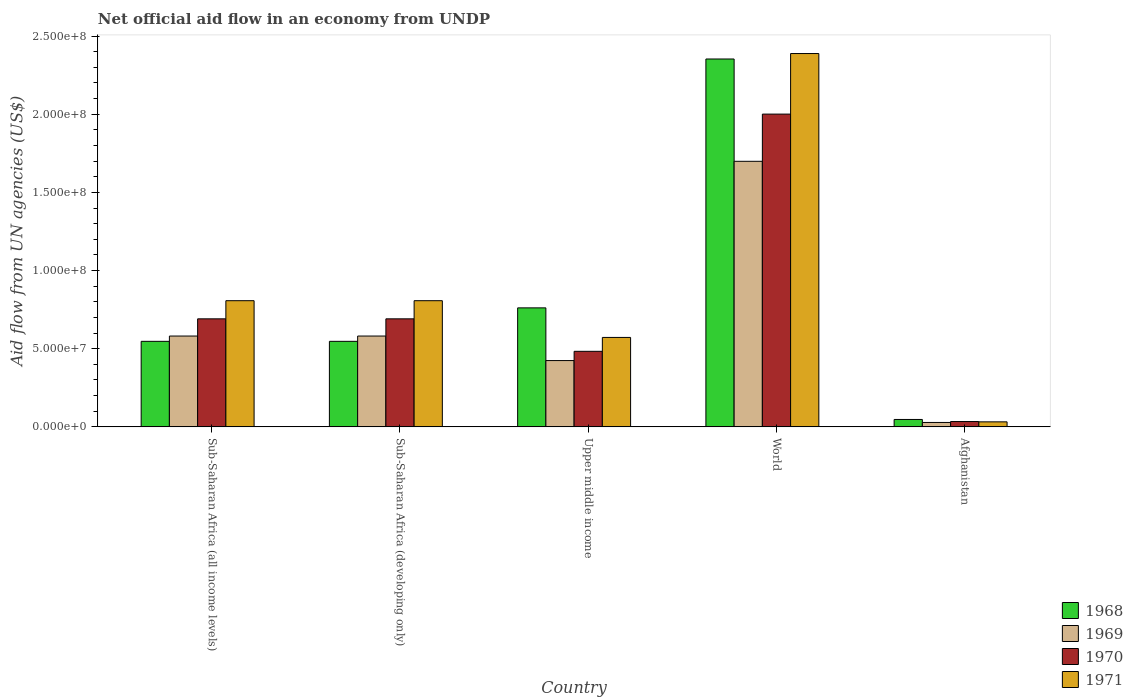Are the number of bars on each tick of the X-axis equal?
Make the answer very short. Yes. How many bars are there on the 2nd tick from the right?
Your response must be concise. 4. What is the label of the 5th group of bars from the left?
Offer a terse response. Afghanistan. In how many cases, is the number of bars for a given country not equal to the number of legend labels?
Your answer should be very brief. 0. What is the net official aid flow in 1970 in World?
Your answer should be very brief. 2.00e+08. Across all countries, what is the maximum net official aid flow in 1968?
Your answer should be very brief. 2.35e+08. Across all countries, what is the minimum net official aid flow in 1968?
Your answer should be very brief. 4.74e+06. In which country was the net official aid flow in 1969 minimum?
Your answer should be compact. Afghanistan. What is the total net official aid flow in 1971 in the graph?
Give a very brief answer. 4.61e+08. What is the difference between the net official aid flow in 1969 in Afghanistan and that in Upper middle income?
Make the answer very short. -3.96e+07. What is the difference between the net official aid flow in 1968 in Sub-Saharan Africa (all income levels) and the net official aid flow in 1969 in World?
Keep it short and to the point. -1.15e+08. What is the average net official aid flow in 1968 per country?
Provide a short and direct response. 8.51e+07. What is the difference between the net official aid flow of/in 1969 and net official aid flow of/in 1970 in Sub-Saharan Africa (developing only)?
Provide a succinct answer. -1.10e+07. In how many countries, is the net official aid flow in 1969 greater than 80000000 US$?
Your answer should be very brief. 1. What is the ratio of the net official aid flow in 1969 in Afghanistan to that in Sub-Saharan Africa (all income levels)?
Your answer should be very brief. 0.05. What is the difference between the highest and the second highest net official aid flow in 1968?
Make the answer very short. 1.81e+08. What is the difference between the highest and the lowest net official aid flow in 1968?
Give a very brief answer. 2.31e+08. What does the 1st bar from the left in World represents?
Give a very brief answer. 1968. Are all the bars in the graph horizontal?
Your answer should be compact. No. How many countries are there in the graph?
Ensure brevity in your answer.  5. What is the difference between two consecutive major ticks on the Y-axis?
Offer a very short reply. 5.00e+07. Are the values on the major ticks of Y-axis written in scientific E-notation?
Offer a terse response. Yes. Does the graph contain grids?
Provide a succinct answer. No. Where does the legend appear in the graph?
Your answer should be very brief. Bottom right. What is the title of the graph?
Offer a very short reply. Net official aid flow in an economy from UNDP. Does "1998" appear as one of the legend labels in the graph?
Give a very brief answer. No. What is the label or title of the Y-axis?
Offer a very short reply. Aid flow from UN agencies (US$). What is the Aid flow from UN agencies (US$) of 1968 in Sub-Saharan Africa (all income levels)?
Your response must be concise. 5.47e+07. What is the Aid flow from UN agencies (US$) of 1969 in Sub-Saharan Africa (all income levels)?
Provide a succinct answer. 5.81e+07. What is the Aid flow from UN agencies (US$) in 1970 in Sub-Saharan Africa (all income levels)?
Give a very brief answer. 6.91e+07. What is the Aid flow from UN agencies (US$) of 1971 in Sub-Saharan Africa (all income levels)?
Provide a short and direct response. 8.07e+07. What is the Aid flow from UN agencies (US$) of 1968 in Sub-Saharan Africa (developing only)?
Make the answer very short. 5.47e+07. What is the Aid flow from UN agencies (US$) in 1969 in Sub-Saharan Africa (developing only)?
Your answer should be compact. 5.81e+07. What is the Aid flow from UN agencies (US$) in 1970 in Sub-Saharan Africa (developing only)?
Your response must be concise. 6.91e+07. What is the Aid flow from UN agencies (US$) of 1971 in Sub-Saharan Africa (developing only)?
Your answer should be very brief. 8.07e+07. What is the Aid flow from UN agencies (US$) of 1968 in Upper middle income?
Your answer should be very brief. 7.61e+07. What is the Aid flow from UN agencies (US$) of 1969 in Upper middle income?
Your answer should be very brief. 4.24e+07. What is the Aid flow from UN agencies (US$) in 1970 in Upper middle income?
Your answer should be compact. 4.83e+07. What is the Aid flow from UN agencies (US$) of 1971 in Upper middle income?
Provide a succinct answer. 5.72e+07. What is the Aid flow from UN agencies (US$) in 1968 in World?
Keep it short and to the point. 2.35e+08. What is the Aid flow from UN agencies (US$) in 1969 in World?
Ensure brevity in your answer.  1.70e+08. What is the Aid flow from UN agencies (US$) of 1970 in World?
Ensure brevity in your answer.  2.00e+08. What is the Aid flow from UN agencies (US$) in 1971 in World?
Give a very brief answer. 2.39e+08. What is the Aid flow from UN agencies (US$) in 1968 in Afghanistan?
Offer a very short reply. 4.74e+06. What is the Aid flow from UN agencies (US$) of 1969 in Afghanistan?
Offer a terse response. 2.82e+06. What is the Aid flow from UN agencies (US$) of 1970 in Afghanistan?
Offer a terse response. 3.41e+06. What is the Aid flow from UN agencies (US$) in 1971 in Afghanistan?
Offer a very short reply. 3.21e+06. Across all countries, what is the maximum Aid flow from UN agencies (US$) in 1968?
Your answer should be very brief. 2.35e+08. Across all countries, what is the maximum Aid flow from UN agencies (US$) of 1969?
Offer a terse response. 1.70e+08. Across all countries, what is the maximum Aid flow from UN agencies (US$) of 1970?
Provide a short and direct response. 2.00e+08. Across all countries, what is the maximum Aid flow from UN agencies (US$) of 1971?
Your answer should be very brief. 2.39e+08. Across all countries, what is the minimum Aid flow from UN agencies (US$) in 1968?
Offer a very short reply. 4.74e+06. Across all countries, what is the minimum Aid flow from UN agencies (US$) of 1969?
Your answer should be very brief. 2.82e+06. Across all countries, what is the minimum Aid flow from UN agencies (US$) in 1970?
Provide a short and direct response. 3.41e+06. Across all countries, what is the minimum Aid flow from UN agencies (US$) in 1971?
Your response must be concise. 3.21e+06. What is the total Aid flow from UN agencies (US$) in 1968 in the graph?
Your response must be concise. 4.26e+08. What is the total Aid flow from UN agencies (US$) in 1969 in the graph?
Provide a succinct answer. 3.31e+08. What is the total Aid flow from UN agencies (US$) in 1970 in the graph?
Provide a succinct answer. 3.90e+08. What is the total Aid flow from UN agencies (US$) in 1971 in the graph?
Your response must be concise. 4.61e+08. What is the difference between the Aid flow from UN agencies (US$) of 1968 in Sub-Saharan Africa (all income levels) and that in Sub-Saharan Africa (developing only)?
Your response must be concise. 0. What is the difference between the Aid flow from UN agencies (US$) of 1969 in Sub-Saharan Africa (all income levels) and that in Sub-Saharan Africa (developing only)?
Offer a very short reply. 0. What is the difference between the Aid flow from UN agencies (US$) of 1968 in Sub-Saharan Africa (all income levels) and that in Upper middle income?
Keep it short and to the point. -2.14e+07. What is the difference between the Aid flow from UN agencies (US$) in 1969 in Sub-Saharan Africa (all income levels) and that in Upper middle income?
Your answer should be compact. 1.57e+07. What is the difference between the Aid flow from UN agencies (US$) of 1970 in Sub-Saharan Africa (all income levels) and that in Upper middle income?
Ensure brevity in your answer.  2.08e+07. What is the difference between the Aid flow from UN agencies (US$) of 1971 in Sub-Saharan Africa (all income levels) and that in Upper middle income?
Your response must be concise. 2.35e+07. What is the difference between the Aid flow from UN agencies (US$) of 1968 in Sub-Saharan Africa (all income levels) and that in World?
Make the answer very short. -1.81e+08. What is the difference between the Aid flow from UN agencies (US$) in 1969 in Sub-Saharan Africa (all income levels) and that in World?
Offer a very short reply. -1.12e+08. What is the difference between the Aid flow from UN agencies (US$) of 1970 in Sub-Saharan Africa (all income levels) and that in World?
Ensure brevity in your answer.  -1.31e+08. What is the difference between the Aid flow from UN agencies (US$) of 1971 in Sub-Saharan Africa (all income levels) and that in World?
Your answer should be very brief. -1.58e+08. What is the difference between the Aid flow from UN agencies (US$) of 1968 in Sub-Saharan Africa (all income levels) and that in Afghanistan?
Offer a very short reply. 5.00e+07. What is the difference between the Aid flow from UN agencies (US$) of 1969 in Sub-Saharan Africa (all income levels) and that in Afghanistan?
Ensure brevity in your answer.  5.53e+07. What is the difference between the Aid flow from UN agencies (US$) in 1970 in Sub-Saharan Africa (all income levels) and that in Afghanistan?
Your answer should be very brief. 6.57e+07. What is the difference between the Aid flow from UN agencies (US$) of 1971 in Sub-Saharan Africa (all income levels) and that in Afghanistan?
Offer a terse response. 7.75e+07. What is the difference between the Aid flow from UN agencies (US$) in 1968 in Sub-Saharan Africa (developing only) and that in Upper middle income?
Keep it short and to the point. -2.14e+07. What is the difference between the Aid flow from UN agencies (US$) in 1969 in Sub-Saharan Africa (developing only) and that in Upper middle income?
Provide a short and direct response. 1.57e+07. What is the difference between the Aid flow from UN agencies (US$) in 1970 in Sub-Saharan Africa (developing only) and that in Upper middle income?
Provide a succinct answer. 2.08e+07. What is the difference between the Aid flow from UN agencies (US$) in 1971 in Sub-Saharan Africa (developing only) and that in Upper middle income?
Provide a short and direct response. 2.35e+07. What is the difference between the Aid flow from UN agencies (US$) of 1968 in Sub-Saharan Africa (developing only) and that in World?
Offer a terse response. -1.81e+08. What is the difference between the Aid flow from UN agencies (US$) of 1969 in Sub-Saharan Africa (developing only) and that in World?
Offer a very short reply. -1.12e+08. What is the difference between the Aid flow from UN agencies (US$) of 1970 in Sub-Saharan Africa (developing only) and that in World?
Offer a terse response. -1.31e+08. What is the difference between the Aid flow from UN agencies (US$) of 1971 in Sub-Saharan Africa (developing only) and that in World?
Your answer should be very brief. -1.58e+08. What is the difference between the Aid flow from UN agencies (US$) in 1968 in Sub-Saharan Africa (developing only) and that in Afghanistan?
Your answer should be very brief. 5.00e+07. What is the difference between the Aid flow from UN agencies (US$) of 1969 in Sub-Saharan Africa (developing only) and that in Afghanistan?
Offer a very short reply. 5.53e+07. What is the difference between the Aid flow from UN agencies (US$) in 1970 in Sub-Saharan Africa (developing only) and that in Afghanistan?
Give a very brief answer. 6.57e+07. What is the difference between the Aid flow from UN agencies (US$) of 1971 in Sub-Saharan Africa (developing only) and that in Afghanistan?
Your response must be concise. 7.75e+07. What is the difference between the Aid flow from UN agencies (US$) in 1968 in Upper middle income and that in World?
Offer a very short reply. -1.59e+08. What is the difference between the Aid flow from UN agencies (US$) in 1969 in Upper middle income and that in World?
Offer a very short reply. -1.27e+08. What is the difference between the Aid flow from UN agencies (US$) of 1970 in Upper middle income and that in World?
Give a very brief answer. -1.52e+08. What is the difference between the Aid flow from UN agencies (US$) in 1971 in Upper middle income and that in World?
Your response must be concise. -1.82e+08. What is the difference between the Aid flow from UN agencies (US$) of 1968 in Upper middle income and that in Afghanistan?
Make the answer very short. 7.14e+07. What is the difference between the Aid flow from UN agencies (US$) of 1969 in Upper middle income and that in Afghanistan?
Your answer should be very brief. 3.96e+07. What is the difference between the Aid flow from UN agencies (US$) in 1970 in Upper middle income and that in Afghanistan?
Your answer should be compact. 4.49e+07. What is the difference between the Aid flow from UN agencies (US$) of 1971 in Upper middle income and that in Afghanistan?
Your answer should be very brief. 5.40e+07. What is the difference between the Aid flow from UN agencies (US$) in 1968 in World and that in Afghanistan?
Your response must be concise. 2.31e+08. What is the difference between the Aid flow from UN agencies (US$) in 1969 in World and that in Afghanistan?
Offer a terse response. 1.67e+08. What is the difference between the Aid flow from UN agencies (US$) of 1970 in World and that in Afghanistan?
Offer a very short reply. 1.97e+08. What is the difference between the Aid flow from UN agencies (US$) of 1971 in World and that in Afghanistan?
Provide a short and direct response. 2.36e+08. What is the difference between the Aid flow from UN agencies (US$) in 1968 in Sub-Saharan Africa (all income levels) and the Aid flow from UN agencies (US$) in 1969 in Sub-Saharan Africa (developing only)?
Offer a very short reply. -3.39e+06. What is the difference between the Aid flow from UN agencies (US$) of 1968 in Sub-Saharan Africa (all income levels) and the Aid flow from UN agencies (US$) of 1970 in Sub-Saharan Africa (developing only)?
Your answer should be very brief. -1.44e+07. What is the difference between the Aid flow from UN agencies (US$) in 1968 in Sub-Saharan Africa (all income levels) and the Aid flow from UN agencies (US$) in 1971 in Sub-Saharan Africa (developing only)?
Provide a succinct answer. -2.60e+07. What is the difference between the Aid flow from UN agencies (US$) in 1969 in Sub-Saharan Africa (all income levels) and the Aid flow from UN agencies (US$) in 1970 in Sub-Saharan Africa (developing only)?
Offer a terse response. -1.10e+07. What is the difference between the Aid flow from UN agencies (US$) in 1969 in Sub-Saharan Africa (all income levels) and the Aid flow from UN agencies (US$) in 1971 in Sub-Saharan Africa (developing only)?
Your answer should be compact. -2.26e+07. What is the difference between the Aid flow from UN agencies (US$) of 1970 in Sub-Saharan Africa (all income levels) and the Aid flow from UN agencies (US$) of 1971 in Sub-Saharan Africa (developing only)?
Keep it short and to the point. -1.16e+07. What is the difference between the Aid flow from UN agencies (US$) of 1968 in Sub-Saharan Africa (all income levels) and the Aid flow from UN agencies (US$) of 1969 in Upper middle income?
Keep it short and to the point. 1.23e+07. What is the difference between the Aid flow from UN agencies (US$) of 1968 in Sub-Saharan Africa (all income levels) and the Aid flow from UN agencies (US$) of 1970 in Upper middle income?
Make the answer very short. 6.38e+06. What is the difference between the Aid flow from UN agencies (US$) in 1968 in Sub-Saharan Africa (all income levels) and the Aid flow from UN agencies (US$) in 1971 in Upper middle income?
Provide a short and direct response. -2.50e+06. What is the difference between the Aid flow from UN agencies (US$) of 1969 in Sub-Saharan Africa (all income levels) and the Aid flow from UN agencies (US$) of 1970 in Upper middle income?
Your answer should be compact. 9.77e+06. What is the difference between the Aid flow from UN agencies (US$) of 1969 in Sub-Saharan Africa (all income levels) and the Aid flow from UN agencies (US$) of 1971 in Upper middle income?
Offer a terse response. 8.90e+05. What is the difference between the Aid flow from UN agencies (US$) in 1970 in Sub-Saharan Africa (all income levels) and the Aid flow from UN agencies (US$) in 1971 in Upper middle income?
Your response must be concise. 1.19e+07. What is the difference between the Aid flow from UN agencies (US$) in 1968 in Sub-Saharan Africa (all income levels) and the Aid flow from UN agencies (US$) in 1969 in World?
Make the answer very short. -1.15e+08. What is the difference between the Aid flow from UN agencies (US$) of 1968 in Sub-Saharan Africa (all income levels) and the Aid flow from UN agencies (US$) of 1970 in World?
Provide a succinct answer. -1.45e+08. What is the difference between the Aid flow from UN agencies (US$) of 1968 in Sub-Saharan Africa (all income levels) and the Aid flow from UN agencies (US$) of 1971 in World?
Your answer should be very brief. -1.84e+08. What is the difference between the Aid flow from UN agencies (US$) of 1969 in Sub-Saharan Africa (all income levels) and the Aid flow from UN agencies (US$) of 1970 in World?
Provide a short and direct response. -1.42e+08. What is the difference between the Aid flow from UN agencies (US$) in 1969 in Sub-Saharan Africa (all income levels) and the Aid flow from UN agencies (US$) in 1971 in World?
Offer a terse response. -1.81e+08. What is the difference between the Aid flow from UN agencies (US$) of 1970 in Sub-Saharan Africa (all income levels) and the Aid flow from UN agencies (US$) of 1971 in World?
Make the answer very short. -1.70e+08. What is the difference between the Aid flow from UN agencies (US$) of 1968 in Sub-Saharan Africa (all income levels) and the Aid flow from UN agencies (US$) of 1969 in Afghanistan?
Ensure brevity in your answer.  5.19e+07. What is the difference between the Aid flow from UN agencies (US$) in 1968 in Sub-Saharan Africa (all income levels) and the Aid flow from UN agencies (US$) in 1970 in Afghanistan?
Offer a terse response. 5.13e+07. What is the difference between the Aid flow from UN agencies (US$) of 1968 in Sub-Saharan Africa (all income levels) and the Aid flow from UN agencies (US$) of 1971 in Afghanistan?
Offer a very short reply. 5.15e+07. What is the difference between the Aid flow from UN agencies (US$) in 1969 in Sub-Saharan Africa (all income levels) and the Aid flow from UN agencies (US$) in 1970 in Afghanistan?
Give a very brief answer. 5.47e+07. What is the difference between the Aid flow from UN agencies (US$) in 1969 in Sub-Saharan Africa (all income levels) and the Aid flow from UN agencies (US$) in 1971 in Afghanistan?
Give a very brief answer. 5.49e+07. What is the difference between the Aid flow from UN agencies (US$) in 1970 in Sub-Saharan Africa (all income levels) and the Aid flow from UN agencies (US$) in 1971 in Afghanistan?
Give a very brief answer. 6.59e+07. What is the difference between the Aid flow from UN agencies (US$) of 1968 in Sub-Saharan Africa (developing only) and the Aid flow from UN agencies (US$) of 1969 in Upper middle income?
Your answer should be compact. 1.23e+07. What is the difference between the Aid flow from UN agencies (US$) of 1968 in Sub-Saharan Africa (developing only) and the Aid flow from UN agencies (US$) of 1970 in Upper middle income?
Offer a very short reply. 6.38e+06. What is the difference between the Aid flow from UN agencies (US$) in 1968 in Sub-Saharan Africa (developing only) and the Aid flow from UN agencies (US$) in 1971 in Upper middle income?
Provide a short and direct response. -2.50e+06. What is the difference between the Aid flow from UN agencies (US$) of 1969 in Sub-Saharan Africa (developing only) and the Aid flow from UN agencies (US$) of 1970 in Upper middle income?
Keep it short and to the point. 9.77e+06. What is the difference between the Aid flow from UN agencies (US$) in 1969 in Sub-Saharan Africa (developing only) and the Aid flow from UN agencies (US$) in 1971 in Upper middle income?
Your answer should be compact. 8.90e+05. What is the difference between the Aid flow from UN agencies (US$) in 1970 in Sub-Saharan Africa (developing only) and the Aid flow from UN agencies (US$) in 1971 in Upper middle income?
Make the answer very short. 1.19e+07. What is the difference between the Aid flow from UN agencies (US$) of 1968 in Sub-Saharan Africa (developing only) and the Aid flow from UN agencies (US$) of 1969 in World?
Ensure brevity in your answer.  -1.15e+08. What is the difference between the Aid flow from UN agencies (US$) in 1968 in Sub-Saharan Africa (developing only) and the Aid flow from UN agencies (US$) in 1970 in World?
Offer a very short reply. -1.45e+08. What is the difference between the Aid flow from UN agencies (US$) of 1968 in Sub-Saharan Africa (developing only) and the Aid flow from UN agencies (US$) of 1971 in World?
Provide a succinct answer. -1.84e+08. What is the difference between the Aid flow from UN agencies (US$) of 1969 in Sub-Saharan Africa (developing only) and the Aid flow from UN agencies (US$) of 1970 in World?
Give a very brief answer. -1.42e+08. What is the difference between the Aid flow from UN agencies (US$) in 1969 in Sub-Saharan Africa (developing only) and the Aid flow from UN agencies (US$) in 1971 in World?
Ensure brevity in your answer.  -1.81e+08. What is the difference between the Aid flow from UN agencies (US$) of 1970 in Sub-Saharan Africa (developing only) and the Aid flow from UN agencies (US$) of 1971 in World?
Your response must be concise. -1.70e+08. What is the difference between the Aid flow from UN agencies (US$) of 1968 in Sub-Saharan Africa (developing only) and the Aid flow from UN agencies (US$) of 1969 in Afghanistan?
Your answer should be very brief. 5.19e+07. What is the difference between the Aid flow from UN agencies (US$) of 1968 in Sub-Saharan Africa (developing only) and the Aid flow from UN agencies (US$) of 1970 in Afghanistan?
Offer a terse response. 5.13e+07. What is the difference between the Aid flow from UN agencies (US$) of 1968 in Sub-Saharan Africa (developing only) and the Aid flow from UN agencies (US$) of 1971 in Afghanistan?
Provide a short and direct response. 5.15e+07. What is the difference between the Aid flow from UN agencies (US$) in 1969 in Sub-Saharan Africa (developing only) and the Aid flow from UN agencies (US$) in 1970 in Afghanistan?
Your response must be concise. 5.47e+07. What is the difference between the Aid flow from UN agencies (US$) in 1969 in Sub-Saharan Africa (developing only) and the Aid flow from UN agencies (US$) in 1971 in Afghanistan?
Keep it short and to the point. 5.49e+07. What is the difference between the Aid flow from UN agencies (US$) of 1970 in Sub-Saharan Africa (developing only) and the Aid flow from UN agencies (US$) of 1971 in Afghanistan?
Your answer should be very brief. 6.59e+07. What is the difference between the Aid flow from UN agencies (US$) in 1968 in Upper middle income and the Aid flow from UN agencies (US$) in 1969 in World?
Provide a short and direct response. -9.38e+07. What is the difference between the Aid flow from UN agencies (US$) of 1968 in Upper middle income and the Aid flow from UN agencies (US$) of 1970 in World?
Offer a terse response. -1.24e+08. What is the difference between the Aid flow from UN agencies (US$) of 1968 in Upper middle income and the Aid flow from UN agencies (US$) of 1971 in World?
Your answer should be compact. -1.63e+08. What is the difference between the Aid flow from UN agencies (US$) in 1969 in Upper middle income and the Aid flow from UN agencies (US$) in 1970 in World?
Offer a very short reply. -1.58e+08. What is the difference between the Aid flow from UN agencies (US$) in 1969 in Upper middle income and the Aid flow from UN agencies (US$) in 1971 in World?
Your answer should be very brief. -1.96e+08. What is the difference between the Aid flow from UN agencies (US$) of 1970 in Upper middle income and the Aid flow from UN agencies (US$) of 1971 in World?
Provide a succinct answer. -1.90e+08. What is the difference between the Aid flow from UN agencies (US$) of 1968 in Upper middle income and the Aid flow from UN agencies (US$) of 1969 in Afghanistan?
Keep it short and to the point. 7.33e+07. What is the difference between the Aid flow from UN agencies (US$) of 1968 in Upper middle income and the Aid flow from UN agencies (US$) of 1970 in Afghanistan?
Keep it short and to the point. 7.27e+07. What is the difference between the Aid flow from UN agencies (US$) in 1968 in Upper middle income and the Aid flow from UN agencies (US$) in 1971 in Afghanistan?
Give a very brief answer. 7.29e+07. What is the difference between the Aid flow from UN agencies (US$) in 1969 in Upper middle income and the Aid flow from UN agencies (US$) in 1970 in Afghanistan?
Give a very brief answer. 3.90e+07. What is the difference between the Aid flow from UN agencies (US$) in 1969 in Upper middle income and the Aid flow from UN agencies (US$) in 1971 in Afghanistan?
Provide a succinct answer. 3.92e+07. What is the difference between the Aid flow from UN agencies (US$) in 1970 in Upper middle income and the Aid flow from UN agencies (US$) in 1971 in Afghanistan?
Provide a short and direct response. 4.51e+07. What is the difference between the Aid flow from UN agencies (US$) in 1968 in World and the Aid flow from UN agencies (US$) in 1969 in Afghanistan?
Keep it short and to the point. 2.32e+08. What is the difference between the Aid flow from UN agencies (US$) of 1968 in World and the Aid flow from UN agencies (US$) of 1970 in Afghanistan?
Your answer should be compact. 2.32e+08. What is the difference between the Aid flow from UN agencies (US$) of 1968 in World and the Aid flow from UN agencies (US$) of 1971 in Afghanistan?
Make the answer very short. 2.32e+08. What is the difference between the Aid flow from UN agencies (US$) in 1969 in World and the Aid flow from UN agencies (US$) in 1970 in Afghanistan?
Offer a terse response. 1.66e+08. What is the difference between the Aid flow from UN agencies (US$) in 1969 in World and the Aid flow from UN agencies (US$) in 1971 in Afghanistan?
Offer a very short reply. 1.67e+08. What is the difference between the Aid flow from UN agencies (US$) of 1970 in World and the Aid flow from UN agencies (US$) of 1971 in Afghanistan?
Your response must be concise. 1.97e+08. What is the average Aid flow from UN agencies (US$) of 1968 per country?
Keep it short and to the point. 8.51e+07. What is the average Aid flow from UN agencies (US$) of 1969 per country?
Offer a terse response. 6.63e+07. What is the average Aid flow from UN agencies (US$) of 1970 per country?
Provide a short and direct response. 7.80e+07. What is the average Aid flow from UN agencies (US$) in 1971 per country?
Ensure brevity in your answer.  9.21e+07. What is the difference between the Aid flow from UN agencies (US$) of 1968 and Aid flow from UN agencies (US$) of 1969 in Sub-Saharan Africa (all income levels)?
Your response must be concise. -3.39e+06. What is the difference between the Aid flow from UN agencies (US$) of 1968 and Aid flow from UN agencies (US$) of 1970 in Sub-Saharan Africa (all income levels)?
Give a very brief answer. -1.44e+07. What is the difference between the Aid flow from UN agencies (US$) in 1968 and Aid flow from UN agencies (US$) in 1971 in Sub-Saharan Africa (all income levels)?
Offer a very short reply. -2.60e+07. What is the difference between the Aid flow from UN agencies (US$) in 1969 and Aid flow from UN agencies (US$) in 1970 in Sub-Saharan Africa (all income levels)?
Ensure brevity in your answer.  -1.10e+07. What is the difference between the Aid flow from UN agencies (US$) of 1969 and Aid flow from UN agencies (US$) of 1971 in Sub-Saharan Africa (all income levels)?
Your answer should be compact. -2.26e+07. What is the difference between the Aid flow from UN agencies (US$) of 1970 and Aid flow from UN agencies (US$) of 1971 in Sub-Saharan Africa (all income levels)?
Your response must be concise. -1.16e+07. What is the difference between the Aid flow from UN agencies (US$) of 1968 and Aid flow from UN agencies (US$) of 1969 in Sub-Saharan Africa (developing only)?
Provide a succinct answer. -3.39e+06. What is the difference between the Aid flow from UN agencies (US$) in 1968 and Aid flow from UN agencies (US$) in 1970 in Sub-Saharan Africa (developing only)?
Keep it short and to the point. -1.44e+07. What is the difference between the Aid flow from UN agencies (US$) in 1968 and Aid flow from UN agencies (US$) in 1971 in Sub-Saharan Africa (developing only)?
Provide a succinct answer. -2.60e+07. What is the difference between the Aid flow from UN agencies (US$) of 1969 and Aid flow from UN agencies (US$) of 1970 in Sub-Saharan Africa (developing only)?
Provide a succinct answer. -1.10e+07. What is the difference between the Aid flow from UN agencies (US$) in 1969 and Aid flow from UN agencies (US$) in 1971 in Sub-Saharan Africa (developing only)?
Provide a short and direct response. -2.26e+07. What is the difference between the Aid flow from UN agencies (US$) of 1970 and Aid flow from UN agencies (US$) of 1971 in Sub-Saharan Africa (developing only)?
Ensure brevity in your answer.  -1.16e+07. What is the difference between the Aid flow from UN agencies (US$) of 1968 and Aid flow from UN agencies (US$) of 1969 in Upper middle income?
Offer a very short reply. 3.37e+07. What is the difference between the Aid flow from UN agencies (US$) of 1968 and Aid flow from UN agencies (US$) of 1970 in Upper middle income?
Offer a very short reply. 2.78e+07. What is the difference between the Aid flow from UN agencies (US$) in 1968 and Aid flow from UN agencies (US$) in 1971 in Upper middle income?
Ensure brevity in your answer.  1.89e+07. What is the difference between the Aid flow from UN agencies (US$) of 1969 and Aid flow from UN agencies (US$) of 1970 in Upper middle income?
Ensure brevity in your answer.  -5.92e+06. What is the difference between the Aid flow from UN agencies (US$) in 1969 and Aid flow from UN agencies (US$) in 1971 in Upper middle income?
Provide a short and direct response. -1.48e+07. What is the difference between the Aid flow from UN agencies (US$) in 1970 and Aid flow from UN agencies (US$) in 1971 in Upper middle income?
Provide a succinct answer. -8.88e+06. What is the difference between the Aid flow from UN agencies (US$) in 1968 and Aid flow from UN agencies (US$) in 1969 in World?
Keep it short and to the point. 6.54e+07. What is the difference between the Aid flow from UN agencies (US$) of 1968 and Aid flow from UN agencies (US$) of 1970 in World?
Provide a short and direct response. 3.52e+07. What is the difference between the Aid flow from UN agencies (US$) in 1968 and Aid flow from UN agencies (US$) in 1971 in World?
Ensure brevity in your answer.  -3.49e+06. What is the difference between the Aid flow from UN agencies (US$) in 1969 and Aid flow from UN agencies (US$) in 1970 in World?
Make the answer very short. -3.02e+07. What is the difference between the Aid flow from UN agencies (US$) in 1969 and Aid flow from UN agencies (US$) in 1971 in World?
Provide a short and direct response. -6.89e+07. What is the difference between the Aid flow from UN agencies (US$) in 1970 and Aid flow from UN agencies (US$) in 1971 in World?
Make the answer very short. -3.87e+07. What is the difference between the Aid flow from UN agencies (US$) in 1968 and Aid flow from UN agencies (US$) in 1969 in Afghanistan?
Provide a short and direct response. 1.92e+06. What is the difference between the Aid flow from UN agencies (US$) in 1968 and Aid flow from UN agencies (US$) in 1970 in Afghanistan?
Your response must be concise. 1.33e+06. What is the difference between the Aid flow from UN agencies (US$) in 1968 and Aid flow from UN agencies (US$) in 1971 in Afghanistan?
Offer a terse response. 1.53e+06. What is the difference between the Aid flow from UN agencies (US$) of 1969 and Aid flow from UN agencies (US$) of 1970 in Afghanistan?
Provide a succinct answer. -5.90e+05. What is the difference between the Aid flow from UN agencies (US$) in 1969 and Aid flow from UN agencies (US$) in 1971 in Afghanistan?
Your answer should be compact. -3.90e+05. What is the ratio of the Aid flow from UN agencies (US$) in 1968 in Sub-Saharan Africa (all income levels) to that in Sub-Saharan Africa (developing only)?
Offer a terse response. 1. What is the ratio of the Aid flow from UN agencies (US$) of 1968 in Sub-Saharan Africa (all income levels) to that in Upper middle income?
Give a very brief answer. 0.72. What is the ratio of the Aid flow from UN agencies (US$) of 1969 in Sub-Saharan Africa (all income levels) to that in Upper middle income?
Give a very brief answer. 1.37. What is the ratio of the Aid flow from UN agencies (US$) in 1970 in Sub-Saharan Africa (all income levels) to that in Upper middle income?
Provide a short and direct response. 1.43. What is the ratio of the Aid flow from UN agencies (US$) in 1971 in Sub-Saharan Africa (all income levels) to that in Upper middle income?
Offer a terse response. 1.41. What is the ratio of the Aid flow from UN agencies (US$) of 1968 in Sub-Saharan Africa (all income levels) to that in World?
Your response must be concise. 0.23. What is the ratio of the Aid flow from UN agencies (US$) in 1969 in Sub-Saharan Africa (all income levels) to that in World?
Your response must be concise. 0.34. What is the ratio of the Aid flow from UN agencies (US$) of 1970 in Sub-Saharan Africa (all income levels) to that in World?
Keep it short and to the point. 0.35. What is the ratio of the Aid flow from UN agencies (US$) in 1971 in Sub-Saharan Africa (all income levels) to that in World?
Your answer should be very brief. 0.34. What is the ratio of the Aid flow from UN agencies (US$) in 1968 in Sub-Saharan Africa (all income levels) to that in Afghanistan?
Offer a very short reply. 11.54. What is the ratio of the Aid flow from UN agencies (US$) of 1969 in Sub-Saharan Africa (all income levels) to that in Afghanistan?
Offer a terse response. 20.6. What is the ratio of the Aid flow from UN agencies (US$) in 1970 in Sub-Saharan Africa (all income levels) to that in Afghanistan?
Ensure brevity in your answer.  20.27. What is the ratio of the Aid flow from UN agencies (US$) of 1971 in Sub-Saharan Africa (all income levels) to that in Afghanistan?
Your answer should be very brief. 25.14. What is the ratio of the Aid flow from UN agencies (US$) in 1968 in Sub-Saharan Africa (developing only) to that in Upper middle income?
Make the answer very short. 0.72. What is the ratio of the Aid flow from UN agencies (US$) in 1969 in Sub-Saharan Africa (developing only) to that in Upper middle income?
Give a very brief answer. 1.37. What is the ratio of the Aid flow from UN agencies (US$) in 1970 in Sub-Saharan Africa (developing only) to that in Upper middle income?
Make the answer very short. 1.43. What is the ratio of the Aid flow from UN agencies (US$) of 1971 in Sub-Saharan Africa (developing only) to that in Upper middle income?
Ensure brevity in your answer.  1.41. What is the ratio of the Aid flow from UN agencies (US$) of 1968 in Sub-Saharan Africa (developing only) to that in World?
Make the answer very short. 0.23. What is the ratio of the Aid flow from UN agencies (US$) of 1969 in Sub-Saharan Africa (developing only) to that in World?
Your response must be concise. 0.34. What is the ratio of the Aid flow from UN agencies (US$) of 1970 in Sub-Saharan Africa (developing only) to that in World?
Your answer should be compact. 0.35. What is the ratio of the Aid flow from UN agencies (US$) of 1971 in Sub-Saharan Africa (developing only) to that in World?
Make the answer very short. 0.34. What is the ratio of the Aid flow from UN agencies (US$) in 1968 in Sub-Saharan Africa (developing only) to that in Afghanistan?
Keep it short and to the point. 11.54. What is the ratio of the Aid flow from UN agencies (US$) of 1969 in Sub-Saharan Africa (developing only) to that in Afghanistan?
Give a very brief answer. 20.6. What is the ratio of the Aid flow from UN agencies (US$) of 1970 in Sub-Saharan Africa (developing only) to that in Afghanistan?
Keep it short and to the point. 20.27. What is the ratio of the Aid flow from UN agencies (US$) in 1971 in Sub-Saharan Africa (developing only) to that in Afghanistan?
Offer a terse response. 25.14. What is the ratio of the Aid flow from UN agencies (US$) of 1968 in Upper middle income to that in World?
Offer a terse response. 0.32. What is the ratio of the Aid flow from UN agencies (US$) in 1969 in Upper middle income to that in World?
Provide a succinct answer. 0.25. What is the ratio of the Aid flow from UN agencies (US$) of 1970 in Upper middle income to that in World?
Offer a terse response. 0.24. What is the ratio of the Aid flow from UN agencies (US$) in 1971 in Upper middle income to that in World?
Give a very brief answer. 0.24. What is the ratio of the Aid flow from UN agencies (US$) of 1968 in Upper middle income to that in Afghanistan?
Offer a very short reply. 16.06. What is the ratio of the Aid flow from UN agencies (US$) in 1969 in Upper middle income to that in Afghanistan?
Your response must be concise. 15.04. What is the ratio of the Aid flow from UN agencies (US$) in 1970 in Upper middle income to that in Afghanistan?
Make the answer very short. 14.17. What is the ratio of the Aid flow from UN agencies (US$) in 1971 in Upper middle income to that in Afghanistan?
Your answer should be compact. 17.82. What is the ratio of the Aid flow from UN agencies (US$) in 1968 in World to that in Afghanistan?
Ensure brevity in your answer.  49.65. What is the ratio of the Aid flow from UN agencies (US$) in 1969 in World to that in Afghanistan?
Give a very brief answer. 60.24. What is the ratio of the Aid flow from UN agencies (US$) of 1970 in World to that in Afghanistan?
Offer a very short reply. 58.67. What is the ratio of the Aid flow from UN agencies (US$) in 1971 in World to that in Afghanistan?
Offer a very short reply. 74.4. What is the difference between the highest and the second highest Aid flow from UN agencies (US$) of 1968?
Your answer should be compact. 1.59e+08. What is the difference between the highest and the second highest Aid flow from UN agencies (US$) of 1969?
Provide a short and direct response. 1.12e+08. What is the difference between the highest and the second highest Aid flow from UN agencies (US$) of 1970?
Your response must be concise. 1.31e+08. What is the difference between the highest and the second highest Aid flow from UN agencies (US$) in 1971?
Keep it short and to the point. 1.58e+08. What is the difference between the highest and the lowest Aid flow from UN agencies (US$) in 1968?
Offer a terse response. 2.31e+08. What is the difference between the highest and the lowest Aid flow from UN agencies (US$) of 1969?
Offer a very short reply. 1.67e+08. What is the difference between the highest and the lowest Aid flow from UN agencies (US$) in 1970?
Ensure brevity in your answer.  1.97e+08. What is the difference between the highest and the lowest Aid flow from UN agencies (US$) in 1971?
Provide a succinct answer. 2.36e+08. 